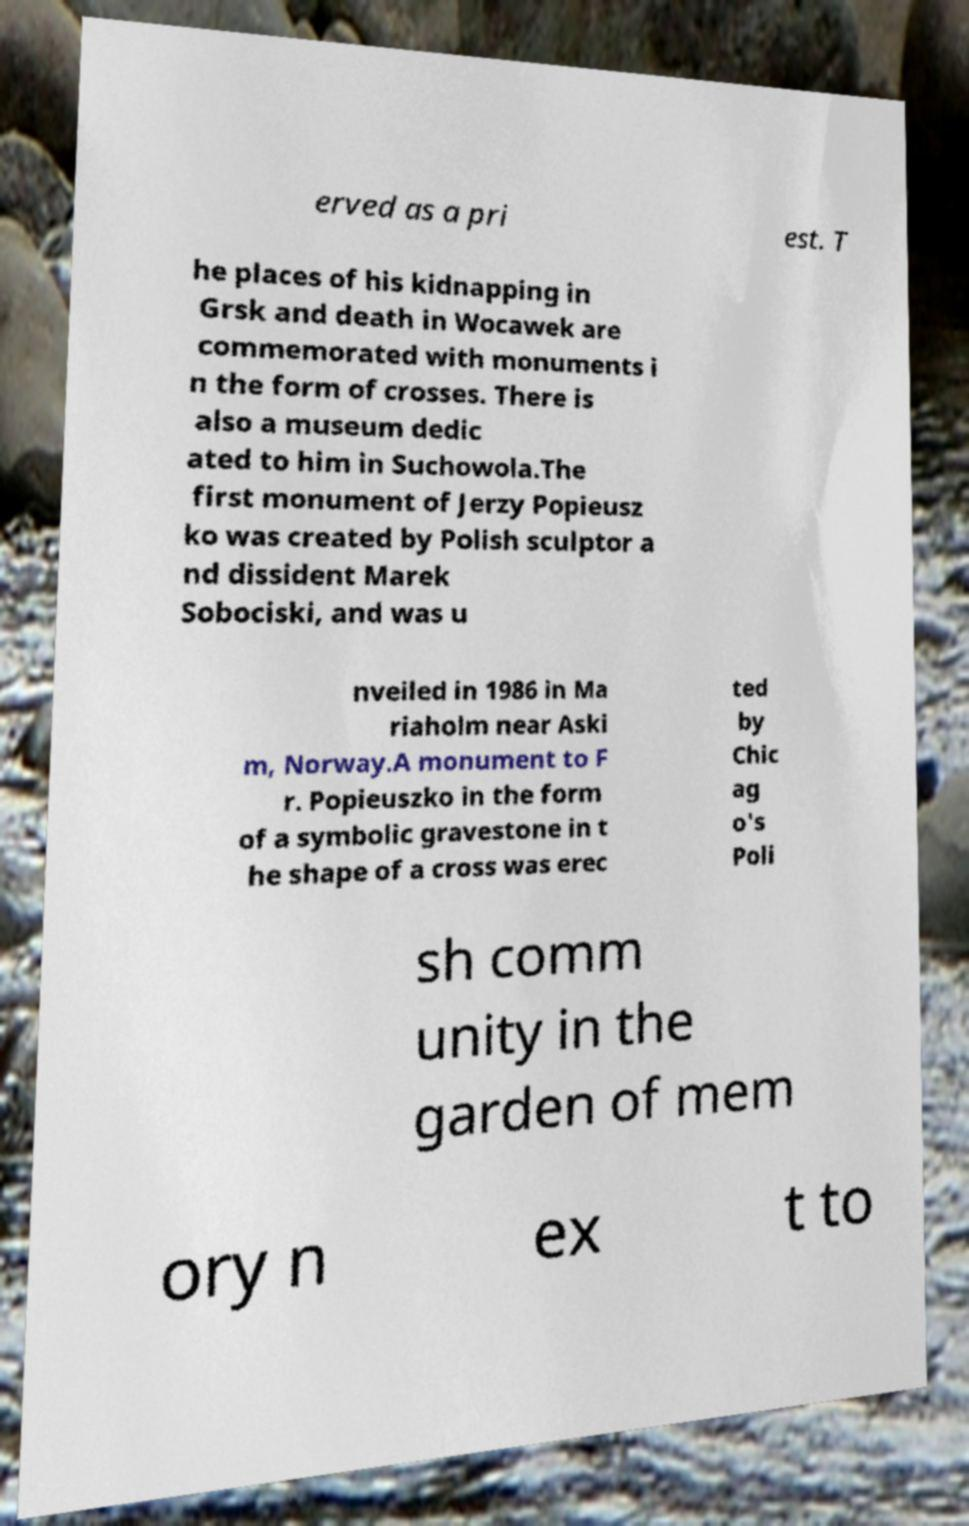Can you read and provide the text displayed in the image?This photo seems to have some interesting text. Can you extract and type it out for me? erved as a pri est. T he places of his kidnapping in Grsk and death in Wocawek are commemorated with monuments i n the form of crosses. There is also a museum dedic ated to him in Suchowola.The first monument of Jerzy Popieusz ko was created by Polish sculptor a nd dissident Marek Sobociski, and was u nveiled in 1986 in Ma riaholm near Aski m, Norway.A monument to F r. Popieuszko in the form of a symbolic gravestone in t he shape of a cross was erec ted by Chic ag o's Poli sh comm unity in the garden of mem ory n ex t to 